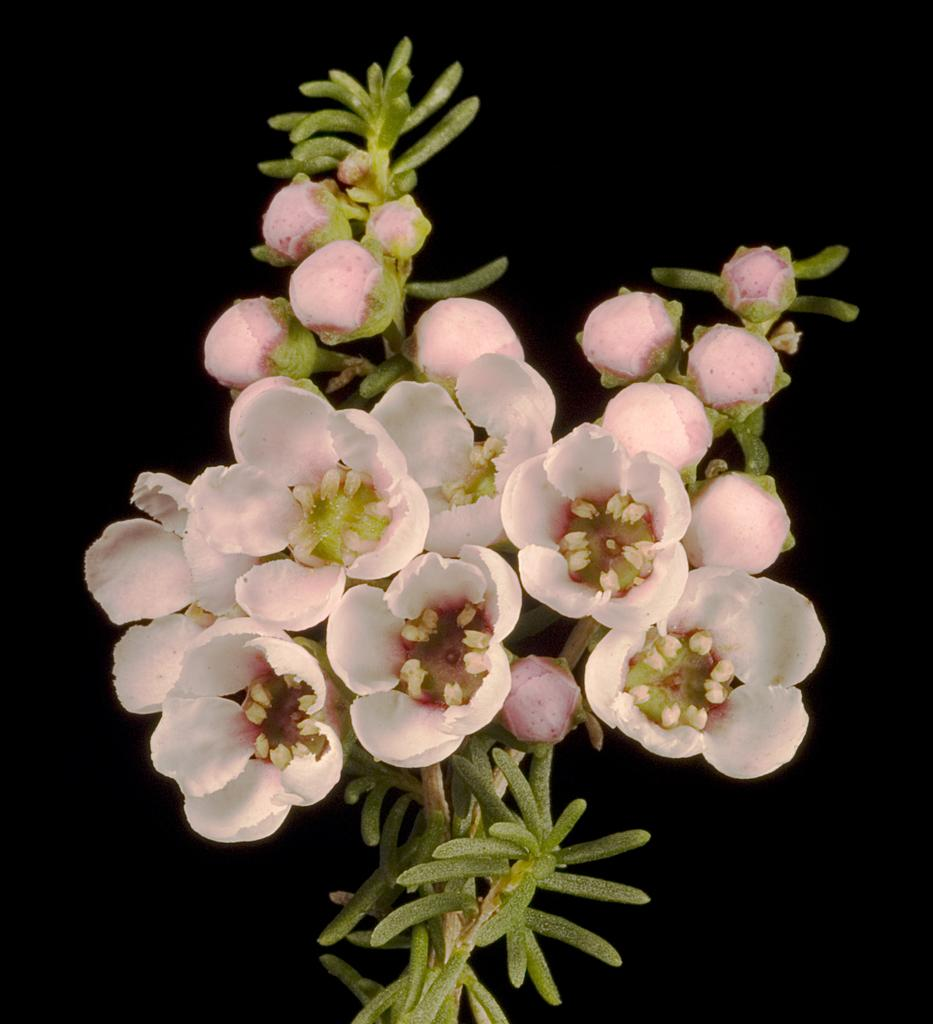What type of plants can be seen in the image? There are flowers in the image. What color are the flowers? The flowers are pink in color. Is there a volcano erupting in the background of the image? There is no volcano present in the image. What type of work is the secretary doing in the image? There is no secretary present in the image. 